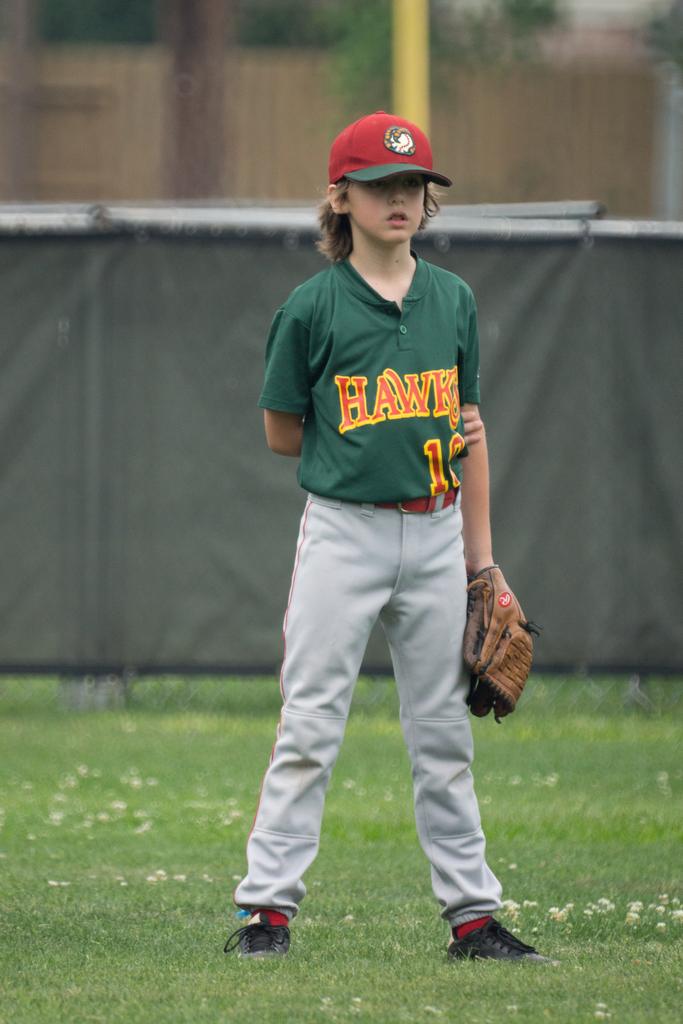What team does the person play for?
Ensure brevity in your answer.  Hawks. What number is the player?
Ensure brevity in your answer.  10. 